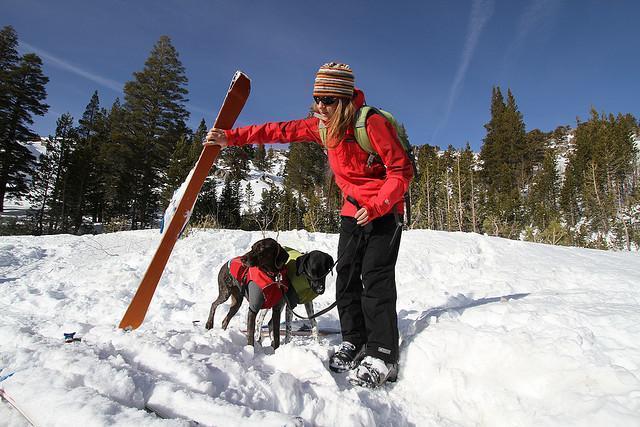How many dogs are in this photograph?
Give a very brief answer. 2. How many dogs are in the picture?
Give a very brief answer. 2. 